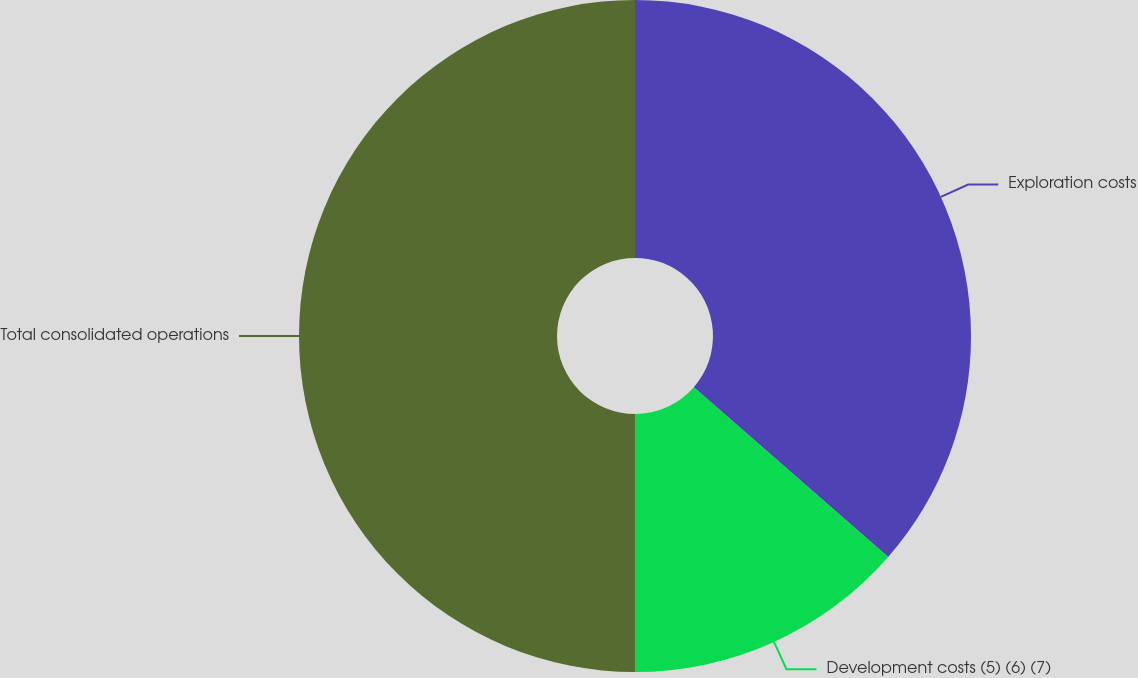<chart> <loc_0><loc_0><loc_500><loc_500><pie_chart><fcel>Exploration costs<fcel>Development costs (5) (6) (7)<fcel>Total consolidated operations<nl><fcel>36.42%<fcel>13.58%<fcel>50.0%<nl></chart> 